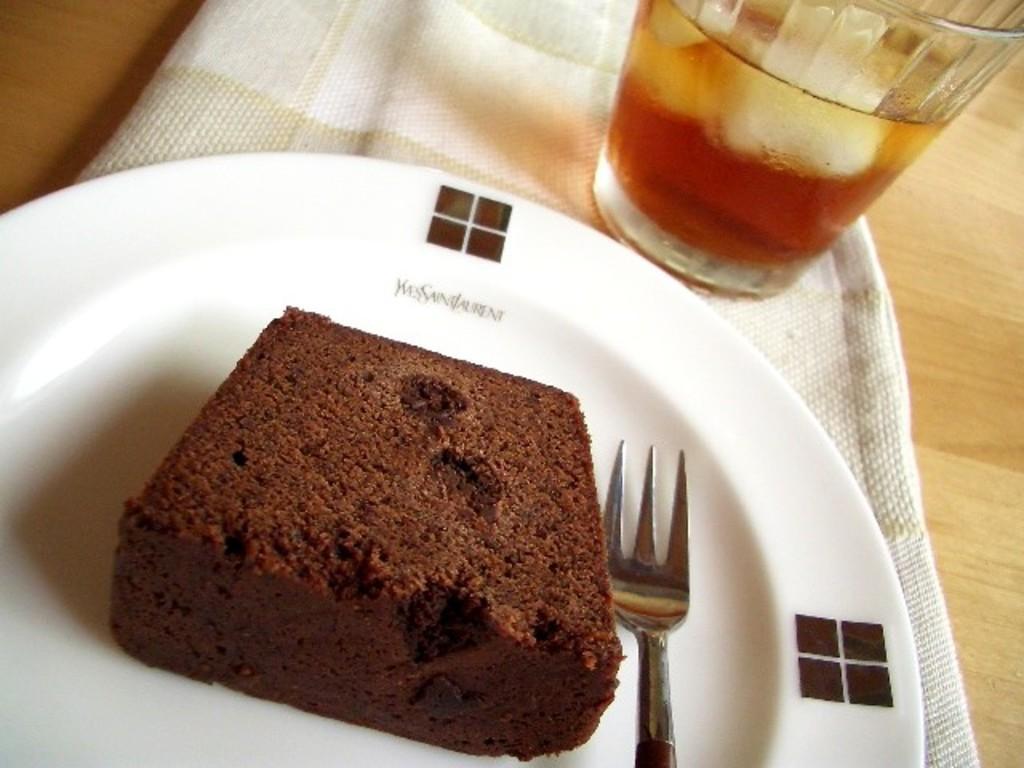Describe this image in one or two sentences. In this image I can see a brownie and a fork on a white plate. There is a glass of drink at the back. There is a cloth on a table. 